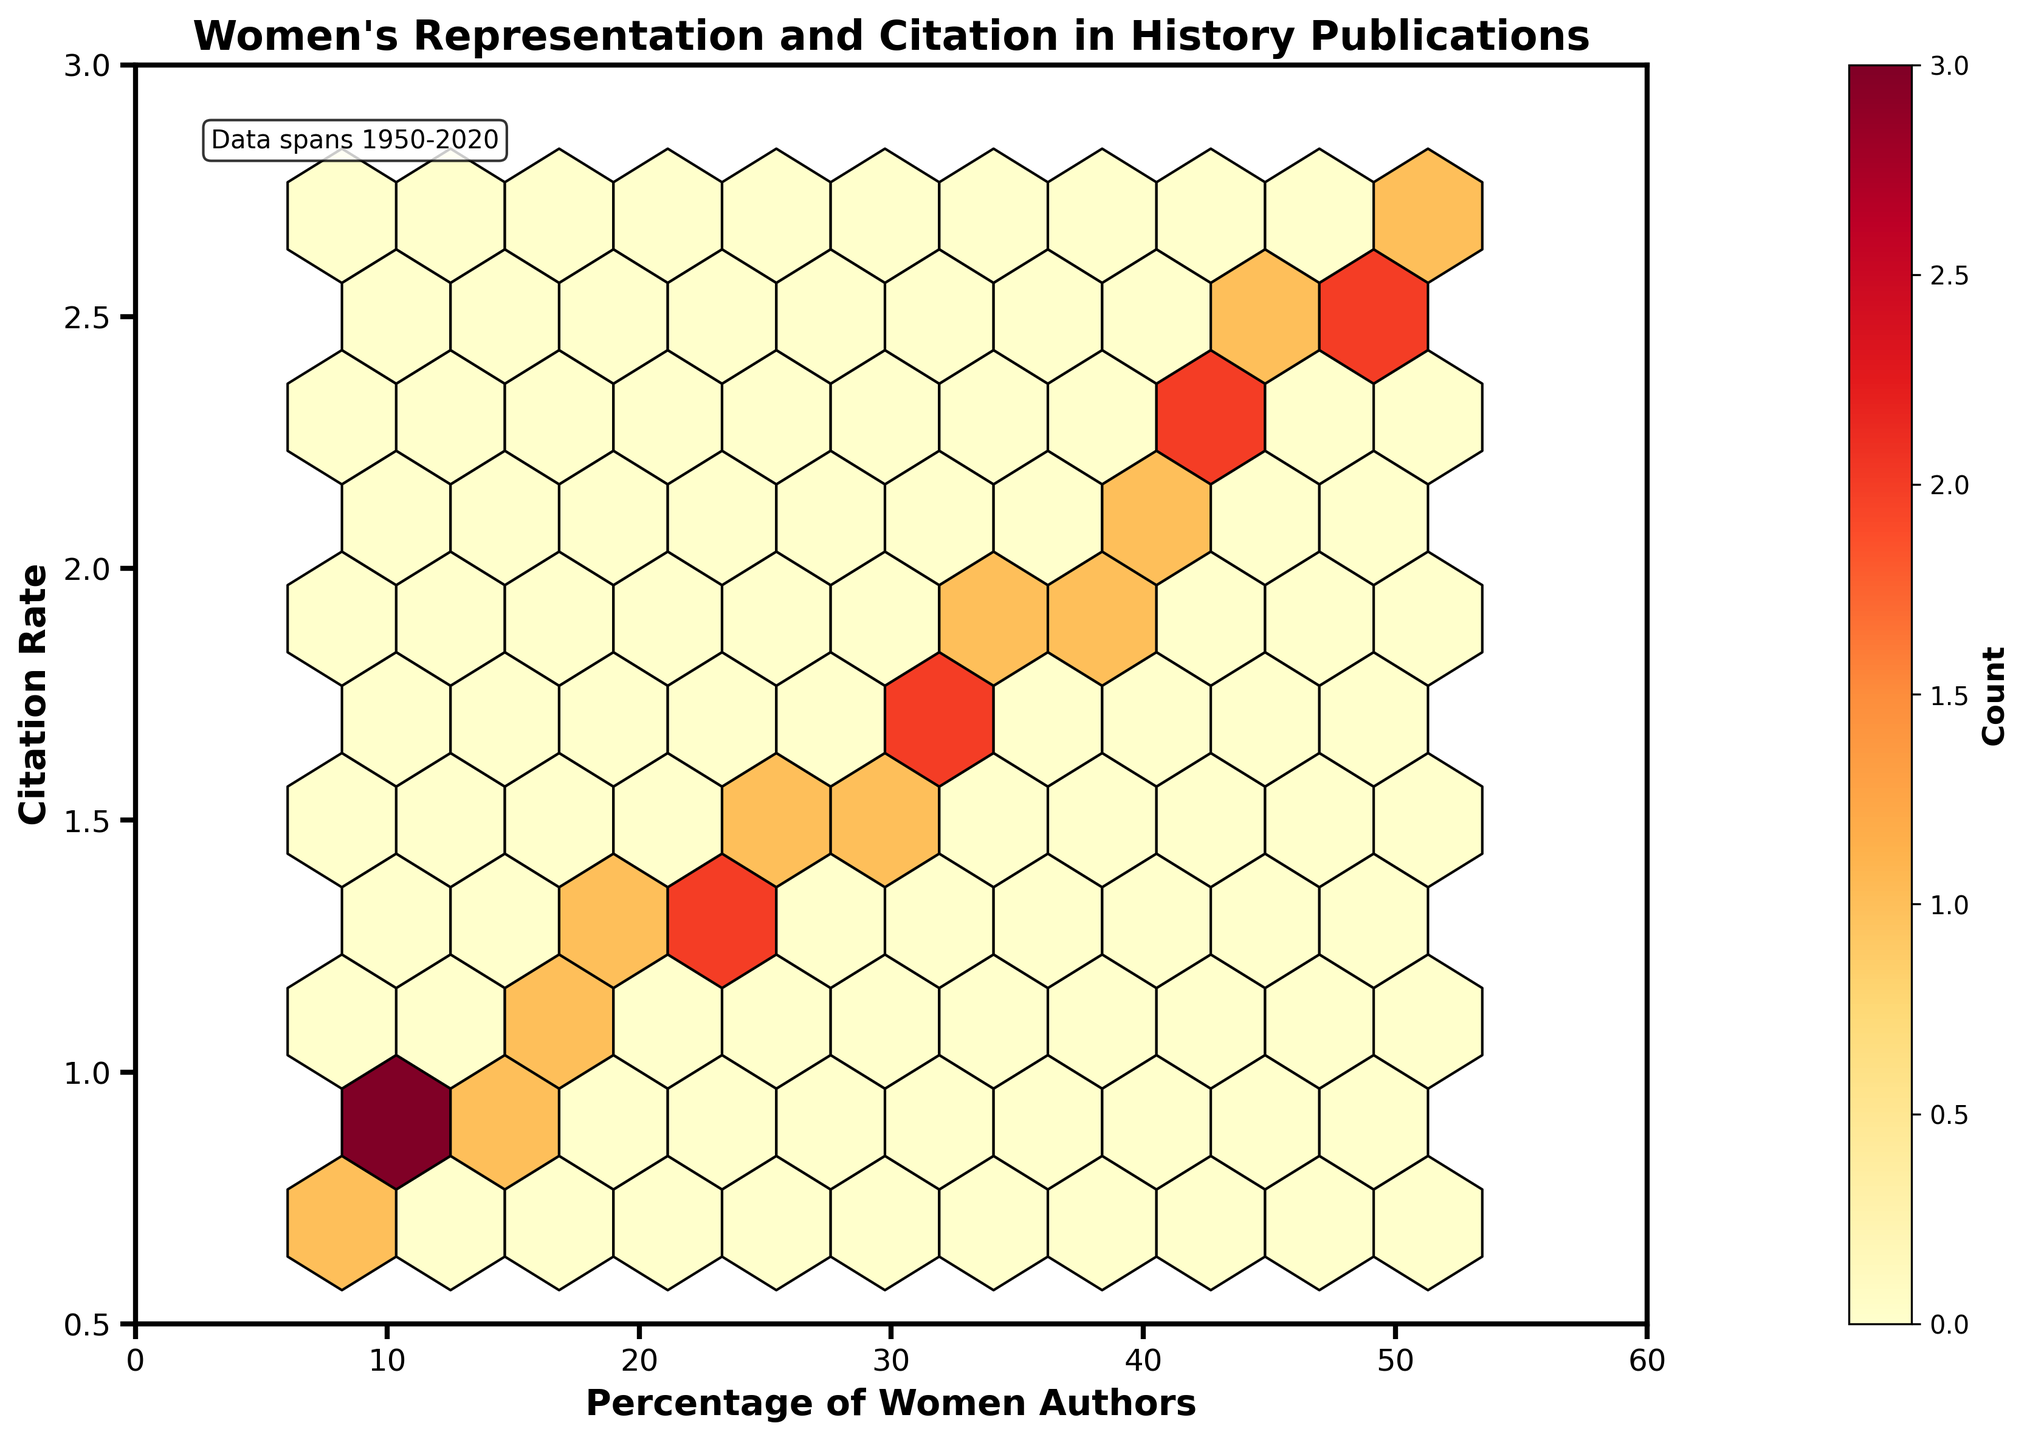What is the range of the y-axis? The range can be determined by looking at the ticks on the y-axis. The y-axis ranges from 0.5 to 3.
Answer: 0.5 to 3 What do the colors in the hexbin plot represent? The color gradient in the plot is explained by the color bar adjacent to the main plot. It indicates the "Count" of observations within each hexbin.
Answer: Count How does the percentage of women authors correlate with citation rates? By observing the general trend and clustering in the hexbin plot, it is visible that as the percentage of women authors increases, the citation rates also tend to increase.
Answer: Positive correlation What is the highest count value on the color bar? By examining the color bar, we can see the highest value it represents. The highest count value is typically indicated at the top end of the color gradient.
Answer: At the highest end (specific value may need a closer look if given) Is there a denser clustering of data points at lower or higher citation rates? By observing the density of hexagons in different areas of the plot, we can determine where the clustering is denser. There is denser clustering at lower citation rates.
Answer: Lower citation rates Compare the citation rates for when women authors constitute 20-30% versus 40-50% of publications. Observing the spread of hexagons in the ranges 20-30% and 40-50% on the x-axis, it's evident that citation rates tend to be higher in the 40-50% range. The data within 40-50% women authors show a higher average for citation rates compared to the 20-30% range.
Answer: Higher in 40-50% range than in 20-30% range What does the annotation in the top left corner indicate? The text annotation located in the top left corner often provides additional context or information about the data. In this case, it informs us that the data spans from the year 1950 to 2020.
Answer: Data spans 1950-2020 